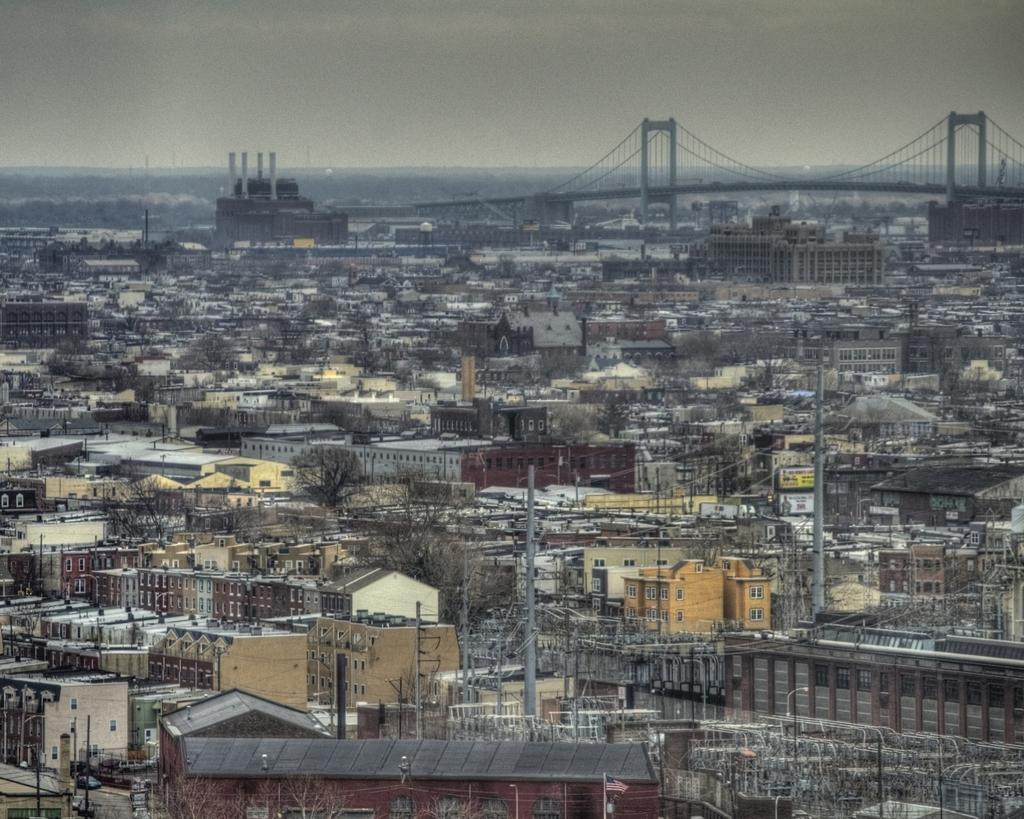What type of structures can be seen in the image? There are buildings in the image. What else can be seen in the image besides buildings? There are poles, wires, and other objects in the image. What is visible in the background of the image? There are trees, a bridge, and the sky visible in the background of the image. How many mountains can be seen in the image? There are no mountains visible in the image. 